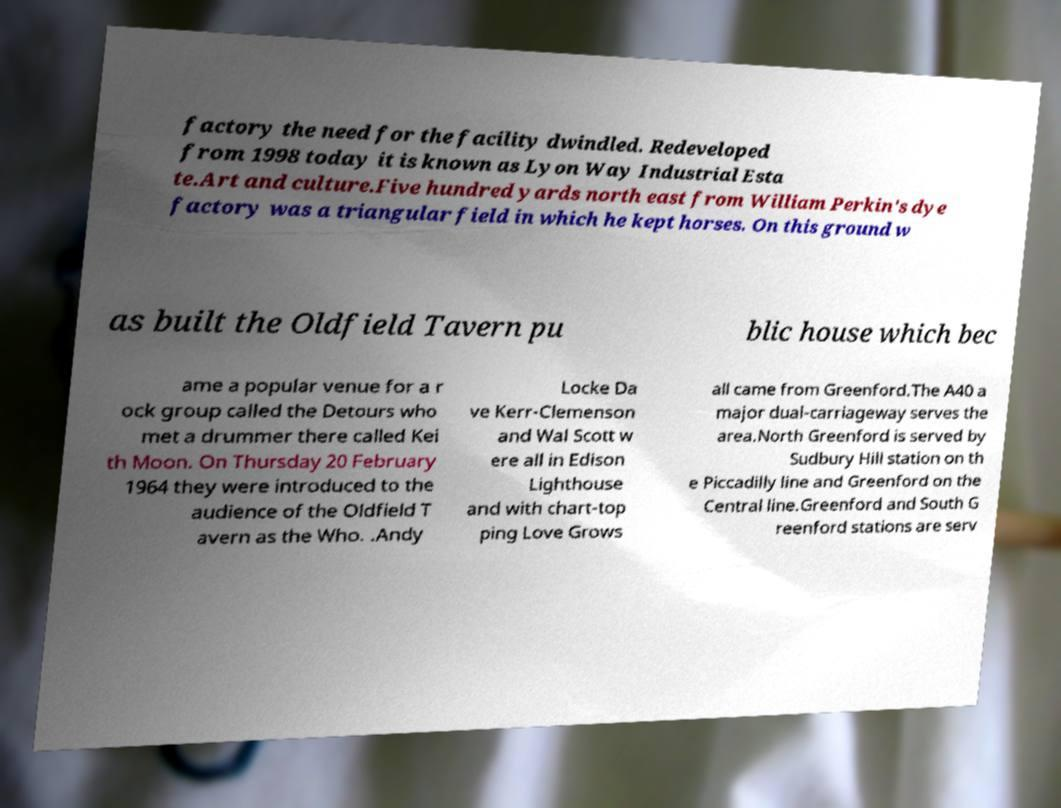Could you assist in decoding the text presented in this image and type it out clearly? factory the need for the facility dwindled. Redeveloped from 1998 today it is known as Lyon Way Industrial Esta te.Art and culture.Five hundred yards north east from William Perkin's dye factory was a triangular field in which he kept horses. On this ground w as built the Oldfield Tavern pu blic house which bec ame a popular venue for a r ock group called the Detours who met a drummer there called Kei th Moon. On Thursday 20 February 1964 they were introduced to the audience of the Oldfield T avern as the Who. .Andy Locke Da ve Kerr-Clemenson and Wal Scott w ere all in Edison Lighthouse and with chart-top ping Love Grows all came from Greenford.The A40 a major dual-carriageway serves the area.North Greenford is served by Sudbury Hill station on th e Piccadilly line and Greenford on the Central line.Greenford and South G reenford stations are serv 